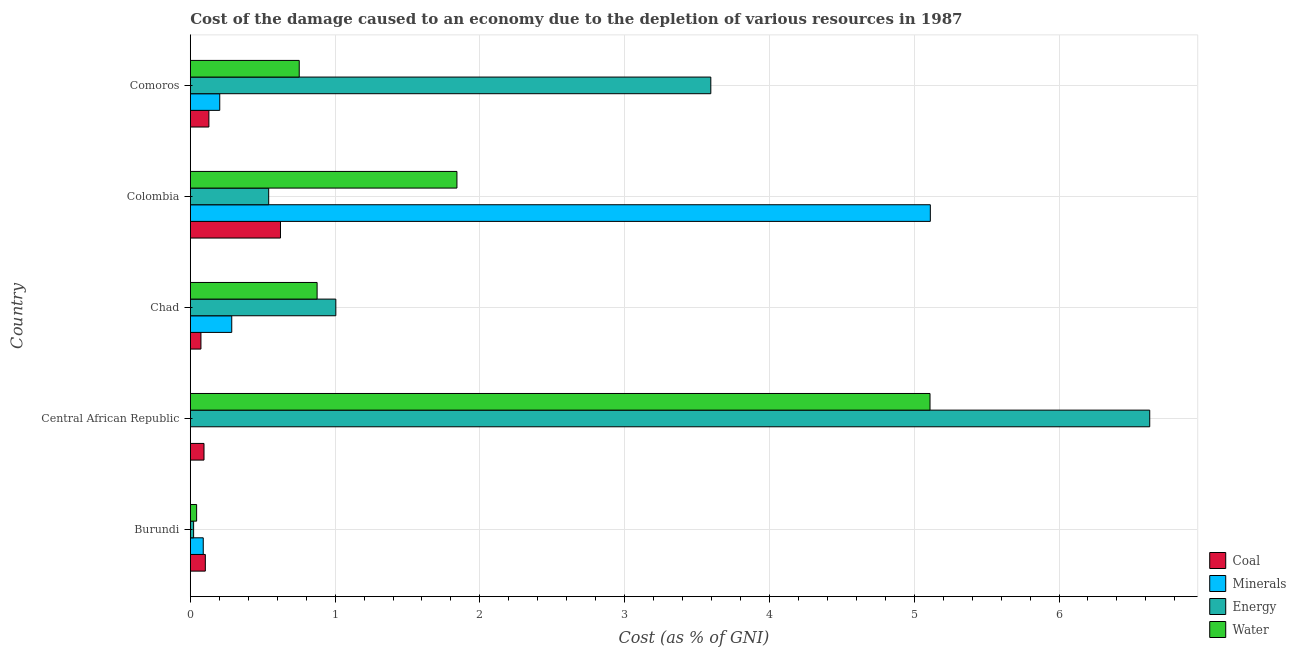How many different coloured bars are there?
Your response must be concise. 4. How many groups of bars are there?
Offer a terse response. 5. How many bars are there on the 1st tick from the top?
Your answer should be very brief. 4. How many bars are there on the 4th tick from the bottom?
Give a very brief answer. 4. What is the label of the 5th group of bars from the top?
Make the answer very short. Burundi. In how many cases, is the number of bars for a given country not equal to the number of legend labels?
Keep it short and to the point. 0. What is the cost of damage due to depletion of water in Chad?
Provide a short and direct response. 0.88. Across all countries, what is the maximum cost of damage due to depletion of water?
Provide a succinct answer. 5.11. Across all countries, what is the minimum cost of damage due to depletion of minerals?
Your answer should be compact. 0. In which country was the cost of damage due to depletion of coal maximum?
Your response must be concise. Colombia. In which country was the cost of damage due to depletion of water minimum?
Offer a very short reply. Burundi. What is the total cost of damage due to depletion of minerals in the graph?
Your response must be concise. 5.69. What is the difference between the cost of damage due to depletion of water in Chad and that in Colombia?
Offer a very short reply. -0.97. What is the difference between the cost of damage due to depletion of energy in Colombia and the cost of damage due to depletion of minerals in Comoros?
Provide a short and direct response. 0.34. What is the average cost of damage due to depletion of water per country?
Make the answer very short. 1.73. What is the difference between the cost of damage due to depletion of coal and cost of damage due to depletion of minerals in Colombia?
Give a very brief answer. -4.49. What is the ratio of the cost of damage due to depletion of energy in Colombia to that in Comoros?
Provide a succinct answer. 0.15. Is the cost of damage due to depletion of water in Colombia less than that in Comoros?
Ensure brevity in your answer.  No. Is the difference between the cost of damage due to depletion of minerals in Central African Republic and Chad greater than the difference between the cost of damage due to depletion of coal in Central African Republic and Chad?
Provide a short and direct response. No. What is the difference between the highest and the second highest cost of damage due to depletion of energy?
Offer a terse response. 3.03. What is the difference between the highest and the lowest cost of damage due to depletion of minerals?
Ensure brevity in your answer.  5.11. In how many countries, is the cost of damage due to depletion of water greater than the average cost of damage due to depletion of water taken over all countries?
Your response must be concise. 2. Is it the case that in every country, the sum of the cost of damage due to depletion of water and cost of damage due to depletion of coal is greater than the sum of cost of damage due to depletion of minerals and cost of damage due to depletion of energy?
Offer a terse response. No. What does the 1st bar from the top in Chad represents?
Give a very brief answer. Water. What does the 3rd bar from the bottom in Burundi represents?
Keep it short and to the point. Energy. Is it the case that in every country, the sum of the cost of damage due to depletion of coal and cost of damage due to depletion of minerals is greater than the cost of damage due to depletion of energy?
Provide a succinct answer. No. How many bars are there?
Provide a succinct answer. 20. How many countries are there in the graph?
Your response must be concise. 5. What is the difference between two consecutive major ticks on the X-axis?
Offer a very short reply. 1. Where does the legend appear in the graph?
Provide a succinct answer. Bottom right. How are the legend labels stacked?
Provide a short and direct response. Vertical. What is the title of the graph?
Offer a terse response. Cost of the damage caused to an economy due to the depletion of various resources in 1987 . Does "Financial sector" appear as one of the legend labels in the graph?
Offer a very short reply. No. What is the label or title of the X-axis?
Keep it short and to the point. Cost (as % of GNI). What is the Cost (as % of GNI) of Coal in Burundi?
Offer a terse response. 0.1. What is the Cost (as % of GNI) in Minerals in Burundi?
Provide a succinct answer. 0.09. What is the Cost (as % of GNI) of Energy in Burundi?
Your response must be concise. 0.02. What is the Cost (as % of GNI) of Water in Burundi?
Your answer should be compact. 0.04. What is the Cost (as % of GNI) in Coal in Central African Republic?
Offer a very short reply. 0.09. What is the Cost (as % of GNI) of Minerals in Central African Republic?
Your response must be concise. 0. What is the Cost (as % of GNI) in Energy in Central African Republic?
Provide a succinct answer. 6.63. What is the Cost (as % of GNI) in Water in Central African Republic?
Provide a short and direct response. 5.11. What is the Cost (as % of GNI) of Coal in Chad?
Your response must be concise. 0.07. What is the Cost (as % of GNI) in Minerals in Chad?
Your answer should be compact. 0.29. What is the Cost (as % of GNI) in Energy in Chad?
Provide a succinct answer. 1.01. What is the Cost (as % of GNI) of Water in Chad?
Keep it short and to the point. 0.88. What is the Cost (as % of GNI) of Coal in Colombia?
Give a very brief answer. 0.62. What is the Cost (as % of GNI) in Minerals in Colombia?
Your answer should be very brief. 5.11. What is the Cost (as % of GNI) of Energy in Colombia?
Your answer should be compact. 0.54. What is the Cost (as % of GNI) of Water in Colombia?
Ensure brevity in your answer.  1.84. What is the Cost (as % of GNI) in Coal in Comoros?
Keep it short and to the point. 0.13. What is the Cost (as % of GNI) of Minerals in Comoros?
Offer a terse response. 0.2. What is the Cost (as % of GNI) in Energy in Comoros?
Offer a terse response. 3.6. What is the Cost (as % of GNI) in Water in Comoros?
Keep it short and to the point. 0.75. Across all countries, what is the maximum Cost (as % of GNI) of Coal?
Provide a succinct answer. 0.62. Across all countries, what is the maximum Cost (as % of GNI) of Minerals?
Ensure brevity in your answer.  5.11. Across all countries, what is the maximum Cost (as % of GNI) of Energy?
Keep it short and to the point. 6.63. Across all countries, what is the maximum Cost (as % of GNI) of Water?
Your response must be concise. 5.11. Across all countries, what is the minimum Cost (as % of GNI) of Coal?
Provide a short and direct response. 0.07. Across all countries, what is the minimum Cost (as % of GNI) in Minerals?
Make the answer very short. 0. Across all countries, what is the minimum Cost (as % of GNI) in Energy?
Your answer should be compact. 0.02. Across all countries, what is the minimum Cost (as % of GNI) in Water?
Keep it short and to the point. 0.04. What is the total Cost (as % of GNI) in Coal in the graph?
Offer a terse response. 1.02. What is the total Cost (as % of GNI) in Minerals in the graph?
Offer a terse response. 5.69. What is the total Cost (as % of GNI) in Energy in the graph?
Offer a terse response. 11.79. What is the total Cost (as % of GNI) in Water in the graph?
Your response must be concise. 8.62. What is the difference between the Cost (as % of GNI) of Coal in Burundi and that in Central African Republic?
Provide a short and direct response. 0.01. What is the difference between the Cost (as % of GNI) in Minerals in Burundi and that in Central African Republic?
Keep it short and to the point. 0.09. What is the difference between the Cost (as % of GNI) of Energy in Burundi and that in Central African Republic?
Provide a succinct answer. -6.6. What is the difference between the Cost (as % of GNI) of Water in Burundi and that in Central African Republic?
Ensure brevity in your answer.  -5.07. What is the difference between the Cost (as % of GNI) in Coal in Burundi and that in Chad?
Make the answer very short. 0.03. What is the difference between the Cost (as % of GNI) in Minerals in Burundi and that in Chad?
Your answer should be very brief. -0.2. What is the difference between the Cost (as % of GNI) of Energy in Burundi and that in Chad?
Ensure brevity in your answer.  -0.98. What is the difference between the Cost (as % of GNI) of Water in Burundi and that in Chad?
Provide a succinct answer. -0.83. What is the difference between the Cost (as % of GNI) in Coal in Burundi and that in Colombia?
Ensure brevity in your answer.  -0.52. What is the difference between the Cost (as % of GNI) in Minerals in Burundi and that in Colombia?
Offer a terse response. -5.02. What is the difference between the Cost (as % of GNI) of Energy in Burundi and that in Colombia?
Give a very brief answer. -0.52. What is the difference between the Cost (as % of GNI) in Water in Burundi and that in Colombia?
Offer a very short reply. -1.8. What is the difference between the Cost (as % of GNI) of Coal in Burundi and that in Comoros?
Provide a short and direct response. -0.02. What is the difference between the Cost (as % of GNI) of Minerals in Burundi and that in Comoros?
Your answer should be compact. -0.11. What is the difference between the Cost (as % of GNI) in Energy in Burundi and that in Comoros?
Keep it short and to the point. -3.57. What is the difference between the Cost (as % of GNI) of Water in Burundi and that in Comoros?
Provide a short and direct response. -0.71. What is the difference between the Cost (as % of GNI) of Coal in Central African Republic and that in Chad?
Give a very brief answer. 0.02. What is the difference between the Cost (as % of GNI) in Minerals in Central African Republic and that in Chad?
Offer a very short reply. -0.29. What is the difference between the Cost (as % of GNI) in Energy in Central African Republic and that in Chad?
Your answer should be very brief. 5.62. What is the difference between the Cost (as % of GNI) in Water in Central African Republic and that in Chad?
Ensure brevity in your answer.  4.23. What is the difference between the Cost (as % of GNI) of Coal in Central African Republic and that in Colombia?
Give a very brief answer. -0.53. What is the difference between the Cost (as % of GNI) of Minerals in Central African Republic and that in Colombia?
Make the answer very short. -5.11. What is the difference between the Cost (as % of GNI) in Energy in Central African Republic and that in Colombia?
Offer a terse response. 6.09. What is the difference between the Cost (as % of GNI) of Water in Central African Republic and that in Colombia?
Provide a succinct answer. 3.27. What is the difference between the Cost (as % of GNI) of Coal in Central African Republic and that in Comoros?
Ensure brevity in your answer.  -0.03. What is the difference between the Cost (as % of GNI) of Minerals in Central African Republic and that in Comoros?
Your answer should be very brief. -0.2. What is the difference between the Cost (as % of GNI) of Energy in Central African Republic and that in Comoros?
Provide a succinct answer. 3.03. What is the difference between the Cost (as % of GNI) of Water in Central African Republic and that in Comoros?
Your response must be concise. 4.36. What is the difference between the Cost (as % of GNI) of Coal in Chad and that in Colombia?
Offer a very short reply. -0.55. What is the difference between the Cost (as % of GNI) in Minerals in Chad and that in Colombia?
Your answer should be very brief. -4.82. What is the difference between the Cost (as % of GNI) of Energy in Chad and that in Colombia?
Offer a terse response. 0.46. What is the difference between the Cost (as % of GNI) in Water in Chad and that in Colombia?
Make the answer very short. -0.97. What is the difference between the Cost (as % of GNI) in Coal in Chad and that in Comoros?
Your answer should be compact. -0.05. What is the difference between the Cost (as % of GNI) of Minerals in Chad and that in Comoros?
Provide a short and direct response. 0.08. What is the difference between the Cost (as % of GNI) of Energy in Chad and that in Comoros?
Offer a terse response. -2.59. What is the difference between the Cost (as % of GNI) in Water in Chad and that in Comoros?
Offer a terse response. 0.12. What is the difference between the Cost (as % of GNI) of Coal in Colombia and that in Comoros?
Give a very brief answer. 0.49. What is the difference between the Cost (as % of GNI) of Minerals in Colombia and that in Comoros?
Give a very brief answer. 4.91. What is the difference between the Cost (as % of GNI) of Energy in Colombia and that in Comoros?
Offer a very short reply. -3.05. What is the difference between the Cost (as % of GNI) of Water in Colombia and that in Comoros?
Make the answer very short. 1.09. What is the difference between the Cost (as % of GNI) in Coal in Burundi and the Cost (as % of GNI) in Minerals in Central African Republic?
Your answer should be compact. 0.1. What is the difference between the Cost (as % of GNI) of Coal in Burundi and the Cost (as % of GNI) of Energy in Central African Republic?
Give a very brief answer. -6.52. What is the difference between the Cost (as % of GNI) of Coal in Burundi and the Cost (as % of GNI) of Water in Central African Republic?
Keep it short and to the point. -5.01. What is the difference between the Cost (as % of GNI) of Minerals in Burundi and the Cost (as % of GNI) of Energy in Central African Republic?
Your response must be concise. -6.54. What is the difference between the Cost (as % of GNI) of Minerals in Burundi and the Cost (as % of GNI) of Water in Central African Republic?
Offer a terse response. -5.02. What is the difference between the Cost (as % of GNI) in Energy in Burundi and the Cost (as % of GNI) in Water in Central African Republic?
Your response must be concise. -5.09. What is the difference between the Cost (as % of GNI) of Coal in Burundi and the Cost (as % of GNI) of Minerals in Chad?
Keep it short and to the point. -0.18. What is the difference between the Cost (as % of GNI) of Coal in Burundi and the Cost (as % of GNI) of Energy in Chad?
Make the answer very short. -0.9. What is the difference between the Cost (as % of GNI) in Coal in Burundi and the Cost (as % of GNI) in Water in Chad?
Provide a succinct answer. -0.77. What is the difference between the Cost (as % of GNI) in Minerals in Burundi and the Cost (as % of GNI) in Energy in Chad?
Your answer should be very brief. -0.92. What is the difference between the Cost (as % of GNI) in Minerals in Burundi and the Cost (as % of GNI) in Water in Chad?
Keep it short and to the point. -0.79. What is the difference between the Cost (as % of GNI) in Energy in Burundi and the Cost (as % of GNI) in Water in Chad?
Your response must be concise. -0.85. What is the difference between the Cost (as % of GNI) of Coal in Burundi and the Cost (as % of GNI) of Minerals in Colombia?
Offer a terse response. -5.01. What is the difference between the Cost (as % of GNI) of Coal in Burundi and the Cost (as % of GNI) of Energy in Colombia?
Ensure brevity in your answer.  -0.44. What is the difference between the Cost (as % of GNI) of Coal in Burundi and the Cost (as % of GNI) of Water in Colombia?
Your answer should be compact. -1.74. What is the difference between the Cost (as % of GNI) in Minerals in Burundi and the Cost (as % of GNI) in Energy in Colombia?
Provide a succinct answer. -0.45. What is the difference between the Cost (as % of GNI) in Minerals in Burundi and the Cost (as % of GNI) in Water in Colombia?
Give a very brief answer. -1.75. What is the difference between the Cost (as % of GNI) of Energy in Burundi and the Cost (as % of GNI) of Water in Colombia?
Offer a very short reply. -1.82. What is the difference between the Cost (as % of GNI) of Coal in Burundi and the Cost (as % of GNI) of Minerals in Comoros?
Provide a succinct answer. -0.1. What is the difference between the Cost (as % of GNI) in Coal in Burundi and the Cost (as % of GNI) in Energy in Comoros?
Your response must be concise. -3.49. What is the difference between the Cost (as % of GNI) of Coal in Burundi and the Cost (as % of GNI) of Water in Comoros?
Your answer should be very brief. -0.65. What is the difference between the Cost (as % of GNI) in Minerals in Burundi and the Cost (as % of GNI) in Energy in Comoros?
Keep it short and to the point. -3.51. What is the difference between the Cost (as % of GNI) of Minerals in Burundi and the Cost (as % of GNI) of Water in Comoros?
Give a very brief answer. -0.66. What is the difference between the Cost (as % of GNI) in Energy in Burundi and the Cost (as % of GNI) in Water in Comoros?
Offer a very short reply. -0.73. What is the difference between the Cost (as % of GNI) in Coal in Central African Republic and the Cost (as % of GNI) in Minerals in Chad?
Your answer should be compact. -0.19. What is the difference between the Cost (as % of GNI) of Coal in Central African Republic and the Cost (as % of GNI) of Energy in Chad?
Your answer should be very brief. -0.91. What is the difference between the Cost (as % of GNI) in Coal in Central African Republic and the Cost (as % of GNI) in Water in Chad?
Ensure brevity in your answer.  -0.78. What is the difference between the Cost (as % of GNI) in Minerals in Central African Republic and the Cost (as % of GNI) in Energy in Chad?
Offer a terse response. -1. What is the difference between the Cost (as % of GNI) of Minerals in Central African Republic and the Cost (as % of GNI) of Water in Chad?
Make the answer very short. -0.88. What is the difference between the Cost (as % of GNI) in Energy in Central African Republic and the Cost (as % of GNI) in Water in Chad?
Your answer should be compact. 5.75. What is the difference between the Cost (as % of GNI) in Coal in Central African Republic and the Cost (as % of GNI) in Minerals in Colombia?
Make the answer very short. -5.02. What is the difference between the Cost (as % of GNI) in Coal in Central African Republic and the Cost (as % of GNI) in Energy in Colombia?
Your answer should be very brief. -0.45. What is the difference between the Cost (as % of GNI) in Coal in Central African Republic and the Cost (as % of GNI) in Water in Colombia?
Make the answer very short. -1.75. What is the difference between the Cost (as % of GNI) of Minerals in Central African Republic and the Cost (as % of GNI) of Energy in Colombia?
Give a very brief answer. -0.54. What is the difference between the Cost (as % of GNI) in Minerals in Central African Republic and the Cost (as % of GNI) in Water in Colombia?
Make the answer very short. -1.84. What is the difference between the Cost (as % of GNI) of Energy in Central African Republic and the Cost (as % of GNI) of Water in Colombia?
Provide a short and direct response. 4.78. What is the difference between the Cost (as % of GNI) of Coal in Central African Republic and the Cost (as % of GNI) of Minerals in Comoros?
Your answer should be compact. -0.11. What is the difference between the Cost (as % of GNI) of Coal in Central African Republic and the Cost (as % of GNI) of Energy in Comoros?
Your answer should be compact. -3.5. What is the difference between the Cost (as % of GNI) in Coal in Central African Republic and the Cost (as % of GNI) in Water in Comoros?
Keep it short and to the point. -0.66. What is the difference between the Cost (as % of GNI) of Minerals in Central African Republic and the Cost (as % of GNI) of Energy in Comoros?
Your answer should be very brief. -3.59. What is the difference between the Cost (as % of GNI) of Minerals in Central African Republic and the Cost (as % of GNI) of Water in Comoros?
Your answer should be compact. -0.75. What is the difference between the Cost (as % of GNI) of Energy in Central African Republic and the Cost (as % of GNI) of Water in Comoros?
Provide a succinct answer. 5.87. What is the difference between the Cost (as % of GNI) of Coal in Chad and the Cost (as % of GNI) of Minerals in Colombia?
Keep it short and to the point. -5.04. What is the difference between the Cost (as % of GNI) in Coal in Chad and the Cost (as % of GNI) in Energy in Colombia?
Your answer should be very brief. -0.47. What is the difference between the Cost (as % of GNI) in Coal in Chad and the Cost (as % of GNI) in Water in Colombia?
Offer a very short reply. -1.77. What is the difference between the Cost (as % of GNI) of Minerals in Chad and the Cost (as % of GNI) of Energy in Colombia?
Give a very brief answer. -0.26. What is the difference between the Cost (as % of GNI) of Minerals in Chad and the Cost (as % of GNI) of Water in Colombia?
Offer a very short reply. -1.56. What is the difference between the Cost (as % of GNI) of Energy in Chad and the Cost (as % of GNI) of Water in Colombia?
Ensure brevity in your answer.  -0.84. What is the difference between the Cost (as % of GNI) of Coal in Chad and the Cost (as % of GNI) of Minerals in Comoros?
Give a very brief answer. -0.13. What is the difference between the Cost (as % of GNI) in Coal in Chad and the Cost (as % of GNI) in Energy in Comoros?
Your answer should be very brief. -3.52. What is the difference between the Cost (as % of GNI) in Coal in Chad and the Cost (as % of GNI) in Water in Comoros?
Offer a terse response. -0.68. What is the difference between the Cost (as % of GNI) of Minerals in Chad and the Cost (as % of GNI) of Energy in Comoros?
Your answer should be compact. -3.31. What is the difference between the Cost (as % of GNI) in Minerals in Chad and the Cost (as % of GNI) in Water in Comoros?
Ensure brevity in your answer.  -0.47. What is the difference between the Cost (as % of GNI) in Energy in Chad and the Cost (as % of GNI) in Water in Comoros?
Your answer should be compact. 0.25. What is the difference between the Cost (as % of GNI) in Coal in Colombia and the Cost (as % of GNI) in Minerals in Comoros?
Make the answer very short. 0.42. What is the difference between the Cost (as % of GNI) in Coal in Colombia and the Cost (as % of GNI) in Energy in Comoros?
Ensure brevity in your answer.  -2.97. What is the difference between the Cost (as % of GNI) in Coal in Colombia and the Cost (as % of GNI) in Water in Comoros?
Ensure brevity in your answer.  -0.13. What is the difference between the Cost (as % of GNI) in Minerals in Colombia and the Cost (as % of GNI) in Energy in Comoros?
Provide a short and direct response. 1.52. What is the difference between the Cost (as % of GNI) in Minerals in Colombia and the Cost (as % of GNI) in Water in Comoros?
Make the answer very short. 4.36. What is the difference between the Cost (as % of GNI) of Energy in Colombia and the Cost (as % of GNI) of Water in Comoros?
Provide a succinct answer. -0.21. What is the average Cost (as % of GNI) in Coal per country?
Keep it short and to the point. 0.2. What is the average Cost (as % of GNI) in Minerals per country?
Give a very brief answer. 1.14. What is the average Cost (as % of GNI) of Energy per country?
Make the answer very short. 2.36. What is the average Cost (as % of GNI) of Water per country?
Offer a very short reply. 1.72. What is the difference between the Cost (as % of GNI) of Coal and Cost (as % of GNI) of Minerals in Burundi?
Keep it short and to the point. 0.01. What is the difference between the Cost (as % of GNI) of Coal and Cost (as % of GNI) of Energy in Burundi?
Give a very brief answer. 0.08. What is the difference between the Cost (as % of GNI) in Coal and Cost (as % of GNI) in Water in Burundi?
Make the answer very short. 0.06. What is the difference between the Cost (as % of GNI) of Minerals and Cost (as % of GNI) of Energy in Burundi?
Your answer should be very brief. 0.07. What is the difference between the Cost (as % of GNI) in Minerals and Cost (as % of GNI) in Water in Burundi?
Give a very brief answer. 0.05. What is the difference between the Cost (as % of GNI) in Energy and Cost (as % of GNI) in Water in Burundi?
Provide a short and direct response. -0.02. What is the difference between the Cost (as % of GNI) of Coal and Cost (as % of GNI) of Minerals in Central African Republic?
Your answer should be very brief. 0.09. What is the difference between the Cost (as % of GNI) of Coal and Cost (as % of GNI) of Energy in Central African Republic?
Your response must be concise. -6.53. What is the difference between the Cost (as % of GNI) of Coal and Cost (as % of GNI) of Water in Central African Republic?
Give a very brief answer. -5.01. What is the difference between the Cost (as % of GNI) of Minerals and Cost (as % of GNI) of Energy in Central African Republic?
Keep it short and to the point. -6.63. What is the difference between the Cost (as % of GNI) in Minerals and Cost (as % of GNI) in Water in Central African Republic?
Your response must be concise. -5.11. What is the difference between the Cost (as % of GNI) in Energy and Cost (as % of GNI) in Water in Central African Republic?
Give a very brief answer. 1.52. What is the difference between the Cost (as % of GNI) in Coal and Cost (as % of GNI) in Minerals in Chad?
Keep it short and to the point. -0.21. What is the difference between the Cost (as % of GNI) in Coal and Cost (as % of GNI) in Energy in Chad?
Give a very brief answer. -0.93. What is the difference between the Cost (as % of GNI) in Coal and Cost (as % of GNI) in Water in Chad?
Offer a terse response. -0.8. What is the difference between the Cost (as % of GNI) in Minerals and Cost (as % of GNI) in Energy in Chad?
Provide a succinct answer. -0.72. What is the difference between the Cost (as % of GNI) of Minerals and Cost (as % of GNI) of Water in Chad?
Offer a terse response. -0.59. What is the difference between the Cost (as % of GNI) in Energy and Cost (as % of GNI) in Water in Chad?
Offer a very short reply. 0.13. What is the difference between the Cost (as % of GNI) of Coal and Cost (as % of GNI) of Minerals in Colombia?
Offer a terse response. -4.49. What is the difference between the Cost (as % of GNI) of Coal and Cost (as % of GNI) of Energy in Colombia?
Your response must be concise. 0.08. What is the difference between the Cost (as % of GNI) of Coal and Cost (as % of GNI) of Water in Colombia?
Give a very brief answer. -1.22. What is the difference between the Cost (as % of GNI) in Minerals and Cost (as % of GNI) in Energy in Colombia?
Your response must be concise. 4.57. What is the difference between the Cost (as % of GNI) in Minerals and Cost (as % of GNI) in Water in Colombia?
Provide a short and direct response. 3.27. What is the difference between the Cost (as % of GNI) in Energy and Cost (as % of GNI) in Water in Colombia?
Offer a terse response. -1.3. What is the difference between the Cost (as % of GNI) of Coal and Cost (as % of GNI) of Minerals in Comoros?
Your response must be concise. -0.07. What is the difference between the Cost (as % of GNI) of Coal and Cost (as % of GNI) of Energy in Comoros?
Provide a short and direct response. -3.47. What is the difference between the Cost (as % of GNI) of Coal and Cost (as % of GNI) of Water in Comoros?
Make the answer very short. -0.62. What is the difference between the Cost (as % of GNI) of Minerals and Cost (as % of GNI) of Energy in Comoros?
Offer a very short reply. -3.39. What is the difference between the Cost (as % of GNI) in Minerals and Cost (as % of GNI) in Water in Comoros?
Offer a very short reply. -0.55. What is the difference between the Cost (as % of GNI) in Energy and Cost (as % of GNI) in Water in Comoros?
Give a very brief answer. 2.84. What is the ratio of the Cost (as % of GNI) in Coal in Burundi to that in Central African Republic?
Provide a succinct answer. 1.1. What is the ratio of the Cost (as % of GNI) in Minerals in Burundi to that in Central African Republic?
Keep it short and to the point. 591.48. What is the ratio of the Cost (as % of GNI) of Energy in Burundi to that in Central African Republic?
Offer a very short reply. 0. What is the ratio of the Cost (as % of GNI) in Water in Burundi to that in Central African Republic?
Your response must be concise. 0.01. What is the ratio of the Cost (as % of GNI) in Coal in Burundi to that in Chad?
Your answer should be very brief. 1.41. What is the ratio of the Cost (as % of GNI) in Minerals in Burundi to that in Chad?
Make the answer very short. 0.31. What is the ratio of the Cost (as % of GNI) in Energy in Burundi to that in Chad?
Your answer should be compact. 0.02. What is the ratio of the Cost (as % of GNI) of Water in Burundi to that in Chad?
Keep it short and to the point. 0.05. What is the ratio of the Cost (as % of GNI) of Coal in Burundi to that in Colombia?
Your answer should be very brief. 0.17. What is the ratio of the Cost (as % of GNI) of Minerals in Burundi to that in Colombia?
Keep it short and to the point. 0.02. What is the ratio of the Cost (as % of GNI) in Energy in Burundi to that in Colombia?
Your response must be concise. 0.04. What is the ratio of the Cost (as % of GNI) of Water in Burundi to that in Colombia?
Ensure brevity in your answer.  0.02. What is the ratio of the Cost (as % of GNI) in Coal in Burundi to that in Comoros?
Give a very brief answer. 0.81. What is the ratio of the Cost (as % of GNI) of Minerals in Burundi to that in Comoros?
Keep it short and to the point. 0.44. What is the ratio of the Cost (as % of GNI) of Energy in Burundi to that in Comoros?
Your answer should be very brief. 0.01. What is the ratio of the Cost (as % of GNI) of Water in Burundi to that in Comoros?
Give a very brief answer. 0.06. What is the ratio of the Cost (as % of GNI) in Coal in Central African Republic to that in Chad?
Your answer should be compact. 1.29. What is the ratio of the Cost (as % of GNI) in Energy in Central African Republic to that in Chad?
Your response must be concise. 6.59. What is the ratio of the Cost (as % of GNI) in Water in Central African Republic to that in Chad?
Make the answer very short. 5.83. What is the ratio of the Cost (as % of GNI) of Coal in Central African Republic to that in Colombia?
Provide a succinct answer. 0.15. What is the ratio of the Cost (as % of GNI) of Energy in Central African Republic to that in Colombia?
Ensure brevity in your answer.  12.24. What is the ratio of the Cost (as % of GNI) in Water in Central African Republic to that in Colombia?
Your answer should be very brief. 2.77. What is the ratio of the Cost (as % of GNI) of Coal in Central African Republic to that in Comoros?
Your answer should be very brief. 0.74. What is the ratio of the Cost (as % of GNI) of Minerals in Central African Republic to that in Comoros?
Your answer should be compact. 0. What is the ratio of the Cost (as % of GNI) of Energy in Central African Republic to that in Comoros?
Keep it short and to the point. 1.84. What is the ratio of the Cost (as % of GNI) in Water in Central African Republic to that in Comoros?
Your answer should be very brief. 6.79. What is the ratio of the Cost (as % of GNI) of Coal in Chad to that in Colombia?
Offer a terse response. 0.12. What is the ratio of the Cost (as % of GNI) in Minerals in Chad to that in Colombia?
Offer a very short reply. 0.06. What is the ratio of the Cost (as % of GNI) of Energy in Chad to that in Colombia?
Your answer should be compact. 1.86. What is the ratio of the Cost (as % of GNI) in Water in Chad to that in Colombia?
Offer a very short reply. 0.48. What is the ratio of the Cost (as % of GNI) of Coal in Chad to that in Comoros?
Provide a short and direct response. 0.57. What is the ratio of the Cost (as % of GNI) of Minerals in Chad to that in Comoros?
Ensure brevity in your answer.  1.41. What is the ratio of the Cost (as % of GNI) of Energy in Chad to that in Comoros?
Provide a short and direct response. 0.28. What is the ratio of the Cost (as % of GNI) in Water in Chad to that in Comoros?
Keep it short and to the point. 1.16. What is the ratio of the Cost (as % of GNI) of Coal in Colombia to that in Comoros?
Keep it short and to the point. 4.85. What is the ratio of the Cost (as % of GNI) of Minerals in Colombia to that in Comoros?
Make the answer very short. 25.12. What is the ratio of the Cost (as % of GNI) of Energy in Colombia to that in Comoros?
Your answer should be very brief. 0.15. What is the ratio of the Cost (as % of GNI) in Water in Colombia to that in Comoros?
Keep it short and to the point. 2.45. What is the difference between the highest and the second highest Cost (as % of GNI) of Coal?
Your response must be concise. 0.49. What is the difference between the highest and the second highest Cost (as % of GNI) in Minerals?
Provide a succinct answer. 4.82. What is the difference between the highest and the second highest Cost (as % of GNI) in Energy?
Provide a succinct answer. 3.03. What is the difference between the highest and the second highest Cost (as % of GNI) of Water?
Offer a very short reply. 3.27. What is the difference between the highest and the lowest Cost (as % of GNI) of Coal?
Offer a terse response. 0.55. What is the difference between the highest and the lowest Cost (as % of GNI) in Minerals?
Offer a terse response. 5.11. What is the difference between the highest and the lowest Cost (as % of GNI) in Energy?
Give a very brief answer. 6.6. What is the difference between the highest and the lowest Cost (as % of GNI) in Water?
Provide a succinct answer. 5.07. 